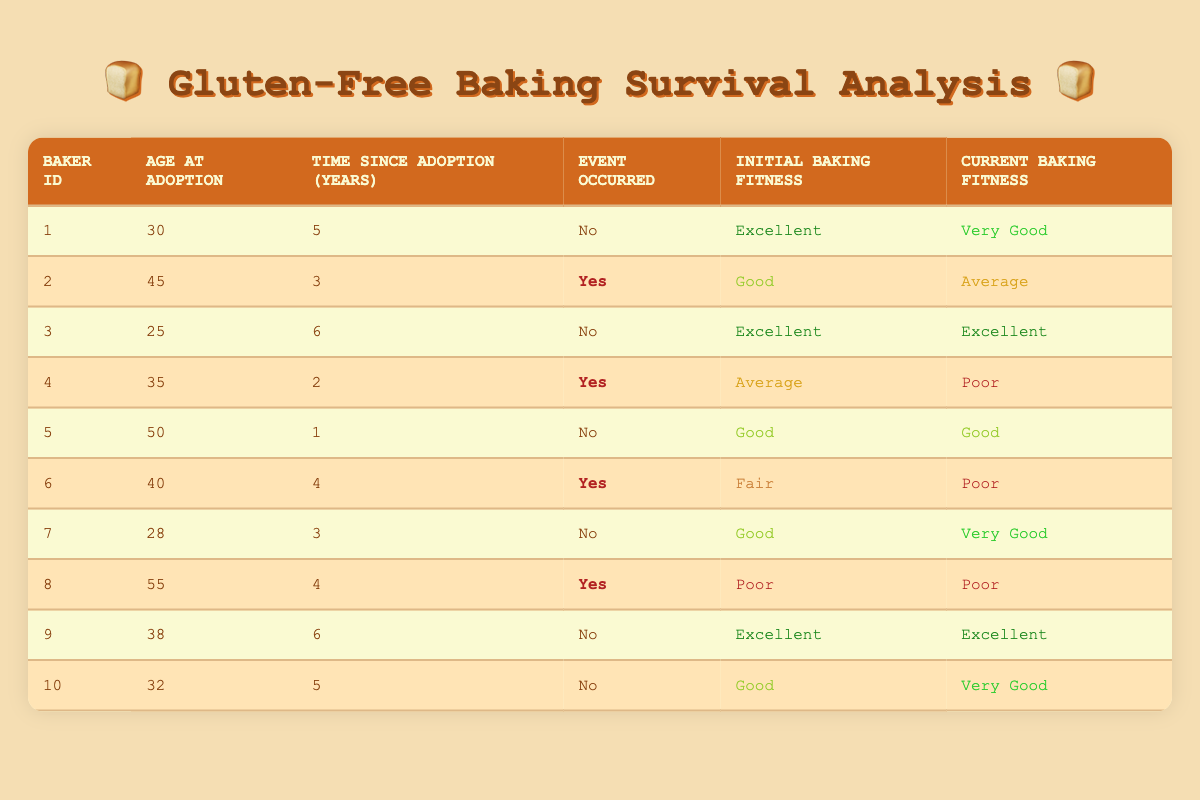What is the current baking fitness of Baker 3? The table shows that Baker 3 has a current baking fitness of "Excellent." This value is directly visible in the row associated with Baker 3.
Answer: Excellent How many bakers experienced an event after adopting a gluten-free lifestyle? By counting the rows where the "Event Occurred" column shows "Yes," we find that 4 bakers experienced an event. Specifically, these bakers are Baker 2, Baker 4, Baker 6, and Baker 8.
Answer: 4 What is the average age of bakers at the time of adoption? To find the average age, we first sum the ages: 30 + 45 + 25 + 35 + 50 + 40 + 28 + 55 + 38 + 32 =  378. Next, we divide by the total number of bakers which is 10: 378 / 10 = 37.8.
Answer: 37.8 Which baker had the longest time since adoption and what is their current baking fitness? The longest time since adoption is 6 years, which applies to both Baker 3 and Baker 9. Both of them have a current baking fitness of "Excellent." We identify this by looking for the maximum value in the "Time Since Adoption" column.
Answer: Excellent Did any bakers start with "poor" initial baking fitness and still remain "poor" after adopting? Yes, Baker 8 started with "Poor" initial baking fitness and has a current fitness status of "Poor." This is confirmed by looking at Baker 8's row, where both initial and current fitness values are noted.
Answer: Yes What is the percentage of bakers who maintained or improved their baking fitness after 3 or more years since adoption? Bakers 1, 3, 9, and 10 are the only ones who maintained or improved their fitness after 3 or more years since adoption. We have 4 such bakers out of a total of 10. Calculating the percentage: (4/10) * 100 = 40%.
Answer: 40% How many bakers improved their baking fitness from good or fair to a status better than average? The bakers who met this criterion are Baker 1, Baker 3, and Baker 10. This is done by reviewing the "Initial Baking Fitness" and "Current Baking Fitness" columns. We see that their initial conditions were better than Fair and improved to at least "Very Good."
Answer: 3 Which age group had the highest initial baking fitness on average? The age groups are as follows: Under 30 (Bakers 1, 3, 7), 30-39 (Bakers 2, 4, 6, 10), 40-49 (Bakers 5, 6), and 50 and above (Baker 8). For Baker group Under 30: average is (Excellent + Excellent + Good) = Excellent. For 30-39: average is (Good + Average + Fair + Good) = Average. For 40-49: Fair. For 50+: Poor. The "Overall Average" is from youngest types, thus Under 30 has the highest initial baking fitness.
Answer: Under 30 